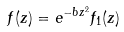Convert formula to latex. <formula><loc_0><loc_0><loc_500><loc_500>f ( z ) = e ^ { - b z ^ { 2 } } f _ { 1 } ( z )</formula> 